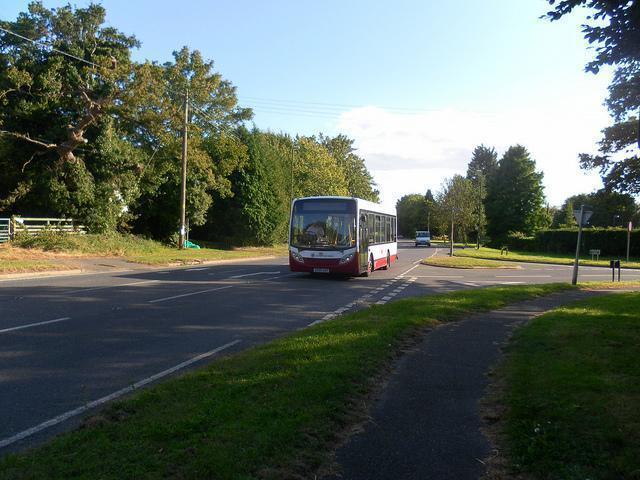Why is the windshield on the bus so large?
Choose the correct response and explain in the format: 'Answer: answer
Rationale: rationale.'
Options: Reinforcement, aerodynamics, visibility, safety. Answer: visibility.
Rationale: Bus drivers need to be able to see in all directions. the positioning of the seat through and size of the vehicle make it difficult. it would be more so if the windshield wasn't so large. 